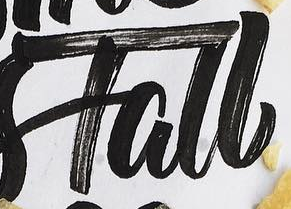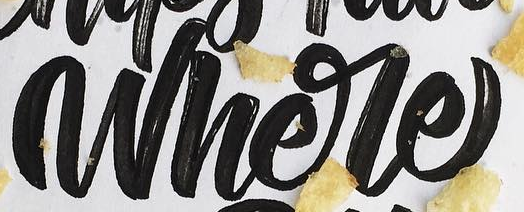What text is displayed in these images sequentially, separated by a semicolon? Tall; Where 